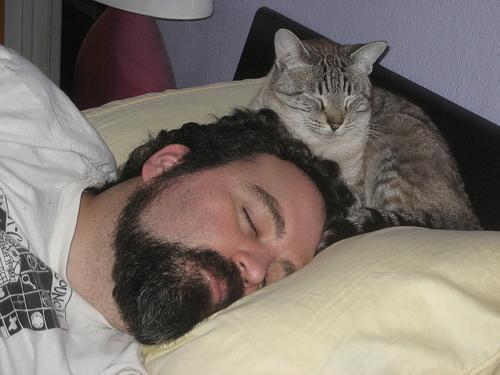How many cats are in the photo?
Give a very brief answer. 1. 